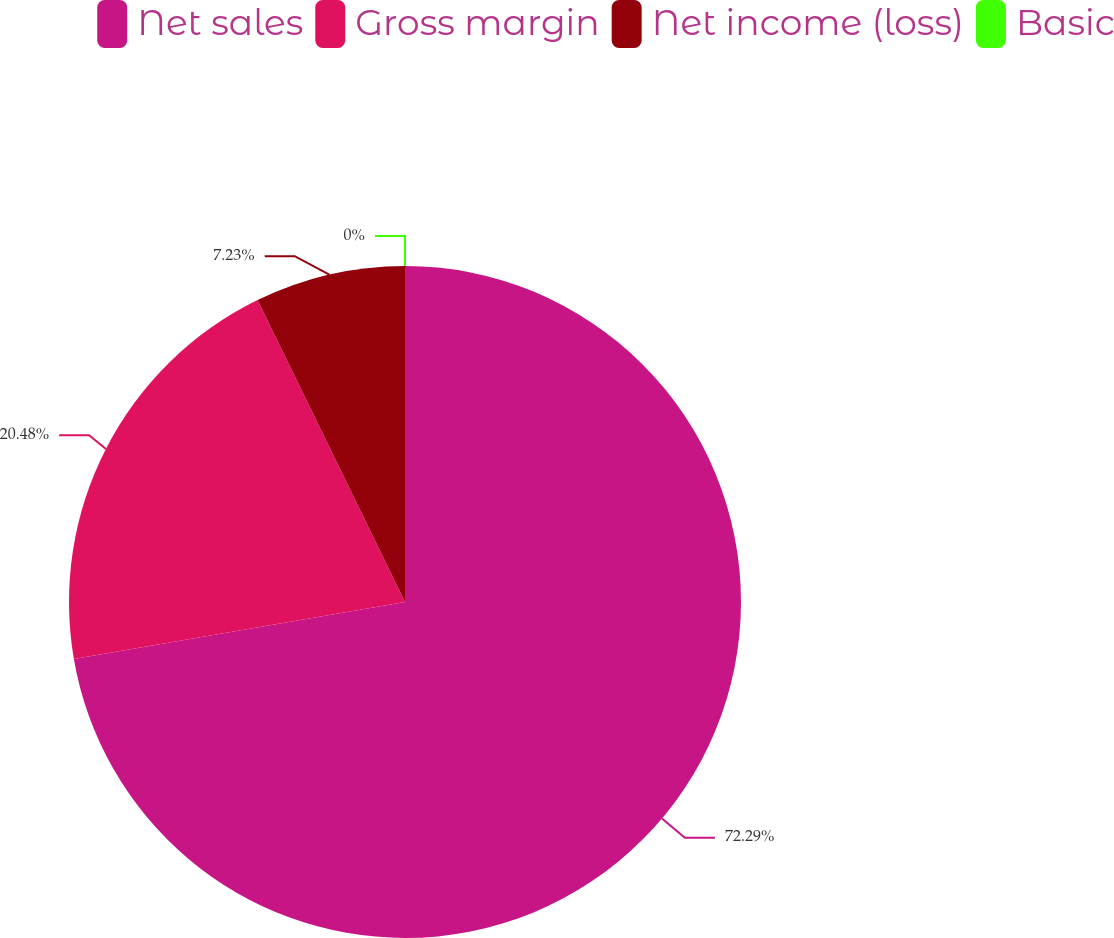Convert chart to OTSL. <chart><loc_0><loc_0><loc_500><loc_500><pie_chart><fcel>Net sales<fcel>Gross margin<fcel>Net income (loss)<fcel>Basic<nl><fcel>72.28%<fcel>20.48%<fcel>7.23%<fcel>0.0%<nl></chart> 